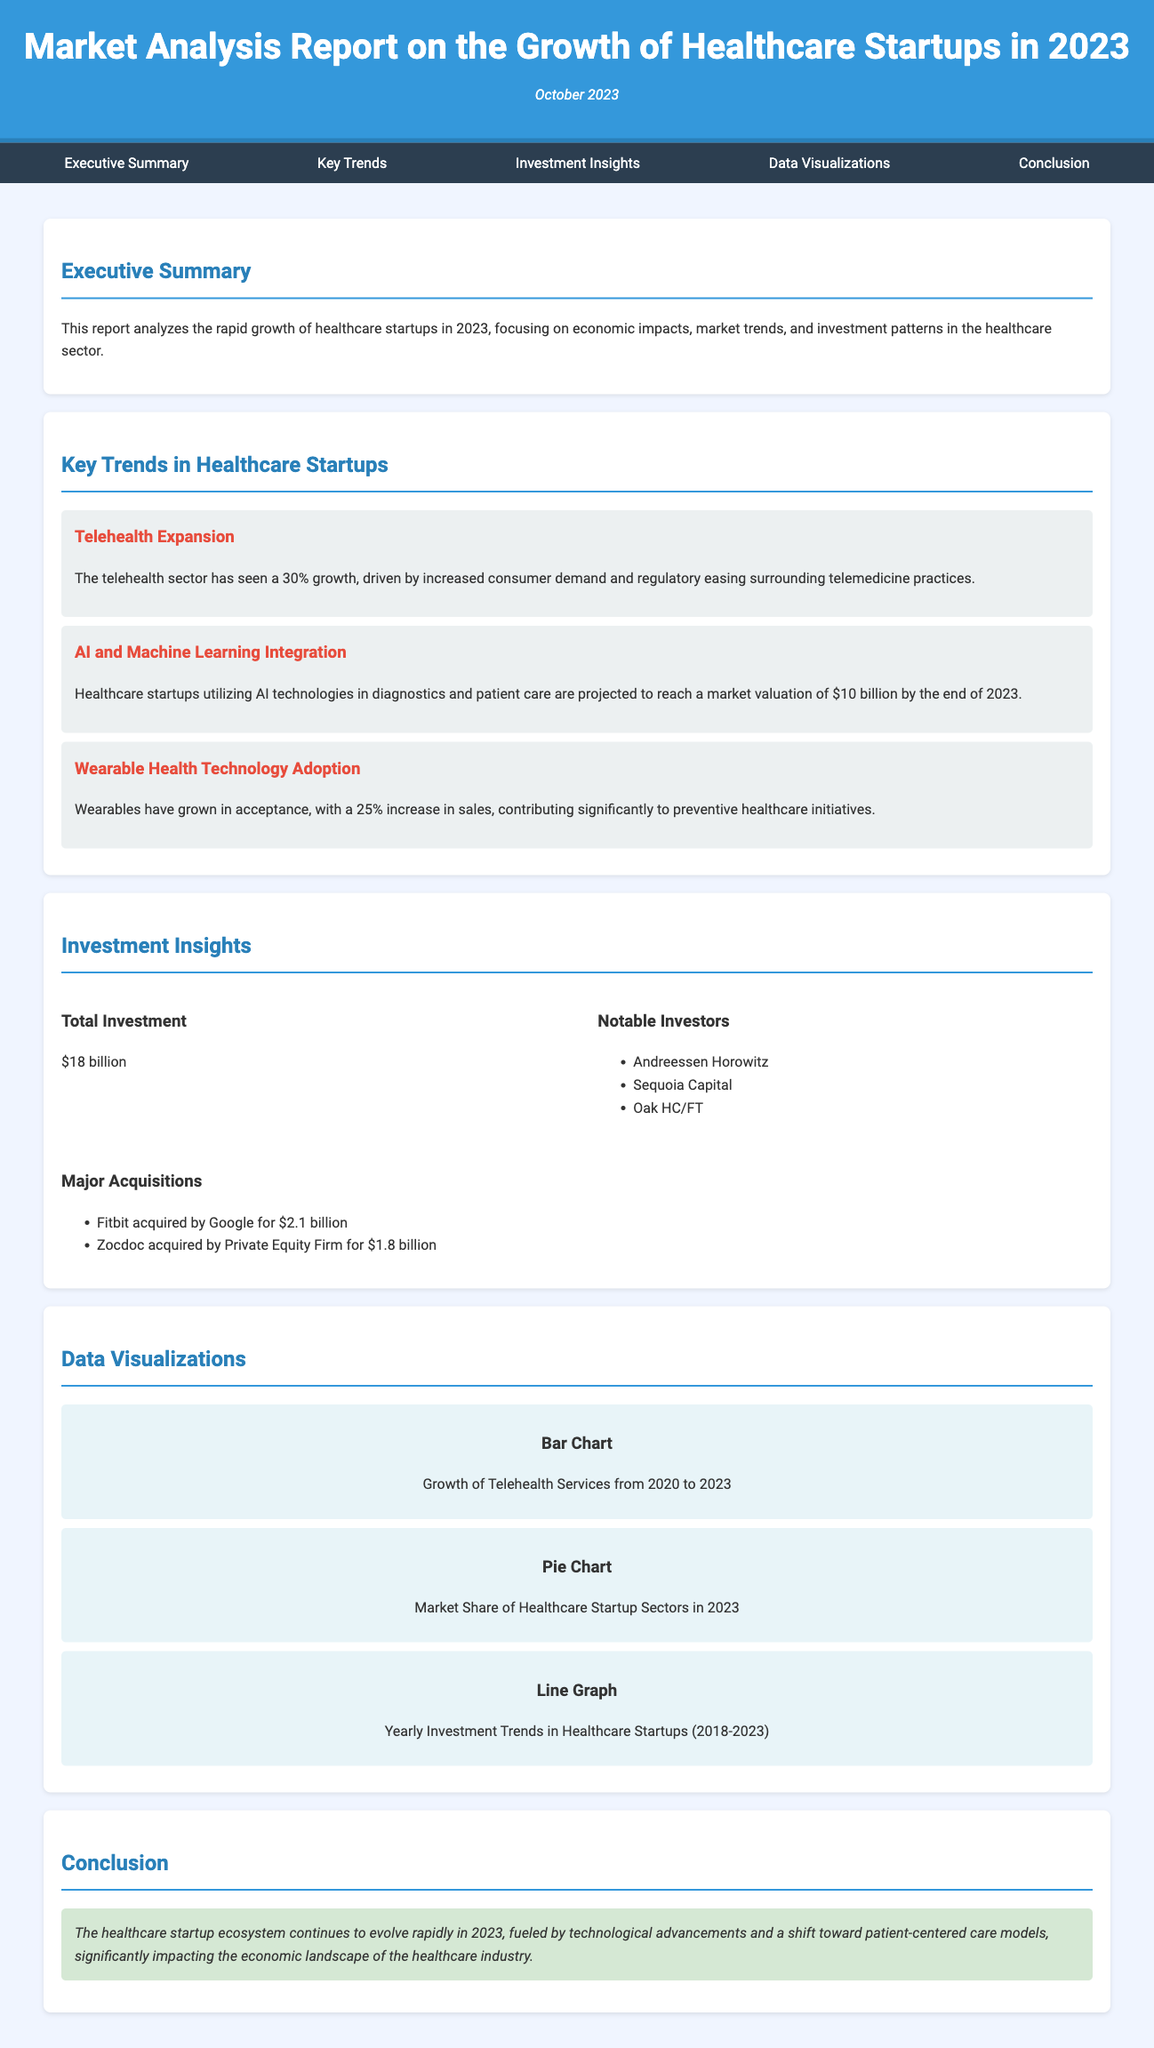What is the total investment in healthcare startups in 2023? The total investment amount is mentioned directly in the Investment Insights section of the document, which states it as $18 billion.
Answer: $18 billion What percentage growth did the telehealth sector experience? The telehealth sector growth percentage is stated in the Key Trends section, which specifies a growth of 30%.
Answer: 30% Who acquired Fitbit? The document lists notable acquisitions, specifically stating that Fitbit was acquired by Google for $2.1 billion.
Answer: Google What is the projected market valuation of healthcare startups utilizing AI technologies by the end of 2023? The report provides a specific projection in the Key Trends section, estimating a market valuation of $10 billion.
Answer: $10 billion Which notable investors are mentioned in the report? The Investment Insights section lists notable investors, which include Andreessen Horowitz, Sequoia Capital, and Oak HC/FT.
Answer: Andreessen Horowitz, Sequoia Capital, Oak HC/FT What type of graph represents yearly investment trends in healthcare startups? The Data Visualizations section describes the type of visualization for yearly investment trends as a line graph.
Answer: Line Graph What was the growth rate of wearable health technology sales? The Key Trends section states that wearable health technology sales saw a 25% increase.
Answer: 25% What date was the report published? The publication date is specified in the header, listed as October 2023.
Answer: October 2023 